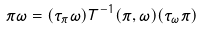<formula> <loc_0><loc_0><loc_500><loc_500>\pi \omega = ( \tau _ { \pi } \omega ) T ^ { - 1 } ( \pi , \omega ) ( \tau _ { \omega } \pi )</formula> 